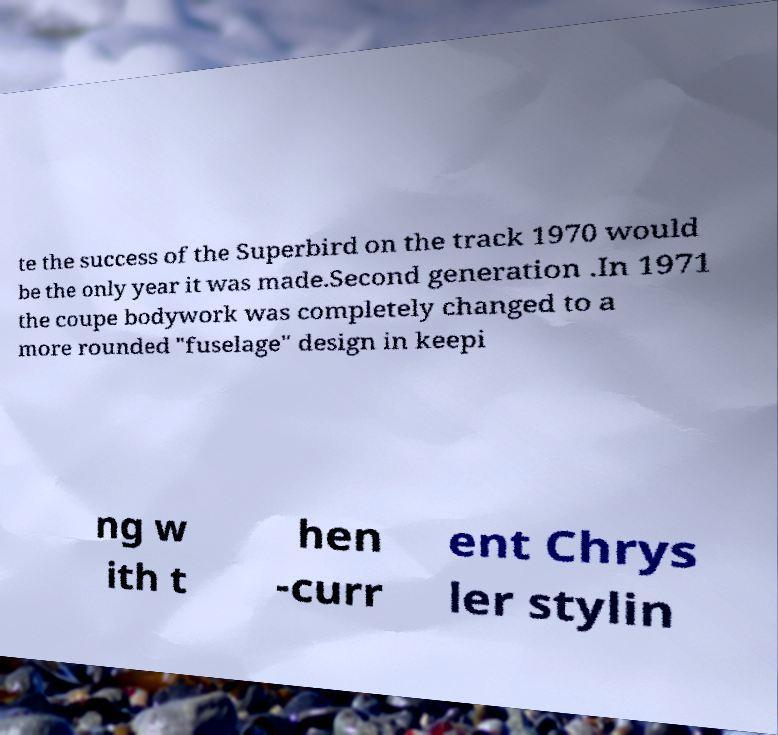Can you accurately transcribe the text from the provided image for me? te the success of the Superbird on the track 1970 would be the only year it was made.Second generation .In 1971 the coupe bodywork was completely changed to a more rounded "fuselage" design in keepi ng w ith t hen -curr ent Chrys ler stylin 